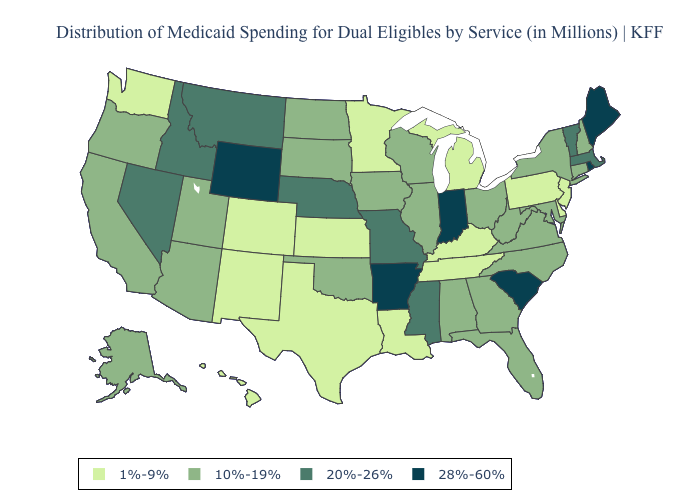Does Arkansas have the highest value in the South?
Short answer required. Yes. Among the states that border Kansas , does Nebraska have the highest value?
Quick response, please. Yes. Does Texas have the highest value in the USA?
Keep it brief. No. Among the states that border Michigan , which have the highest value?
Keep it brief. Indiana. What is the highest value in the USA?
Be succinct. 28%-60%. Does New Hampshire have a higher value than Montana?
Concise answer only. No. What is the highest value in states that border New Hampshire?
Short answer required. 28%-60%. Is the legend a continuous bar?
Write a very short answer. No. Name the states that have a value in the range 10%-19%?
Quick response, please. Alabama, Alaska, Arizona, California, Connecticut, Florida, Georgia, Illinois, Iowa, Maryland, New Hampshire, New York, North Carolina, North Dakota, Ohio, Oklahoma, Oregon, South Dakota, Utah, Virginia, West Virginia, Wisconsin. Name the states that have a value in the range 10%-19%?
Concise answer only. Alabama, Alaska, Arizona, California, Connecticut, Florida, Georgia, Illinois, Iowa, Maryland, New Hampshire, New York, North Carolina, North Dakota, Ohio, Oklahoma, Oregon, South Dakota, Utah, Virginia, West Virginia, Wisconsin. Name the states that have a value in the range 1%-9%?
Keep it brief. Colorado, Delaware, Hawaii, Kansas, Kentucky, Louisiana, Michigan, Minnesota, New Jersey, New Mexico, Pennsylvania, Tennessee, Texas, Washington. Does Arkansas have the lowest value in the USA?
Give a very brief answer. No. Name the states that have a value in the range 20%-26%?
Answer briefly. Idaho, Massachusetts, Mississippi, Missouri, Montana, Nebraska, Nevada, Vermont. Among the states that border West Virginia , which have the highest value?
Write a very short answer. Maryland, Ohio, Virginia. Name the states that have a value in the range 10%-19%?
Concise answer only. Alabama, Alaska, Arizona, California, Connecticut, Florida, Georgia, Illinois, Iowa, Maryland, New Hampshire, New York, North Carolina, North Dakota, Ohio, Oklahoma, Oregon, South Dakota, Utah, Virginia, West Virginia, Wisconsin. 